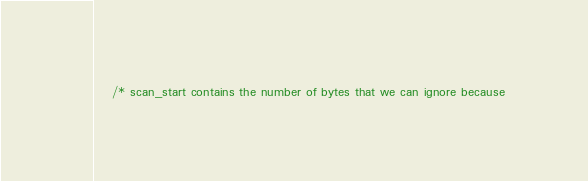Convert code to text. <code><loc_0><loc_0><loc_500><loc_500><_C_>	/* scan_start contains the number of bytes that we can ignore because</code> 